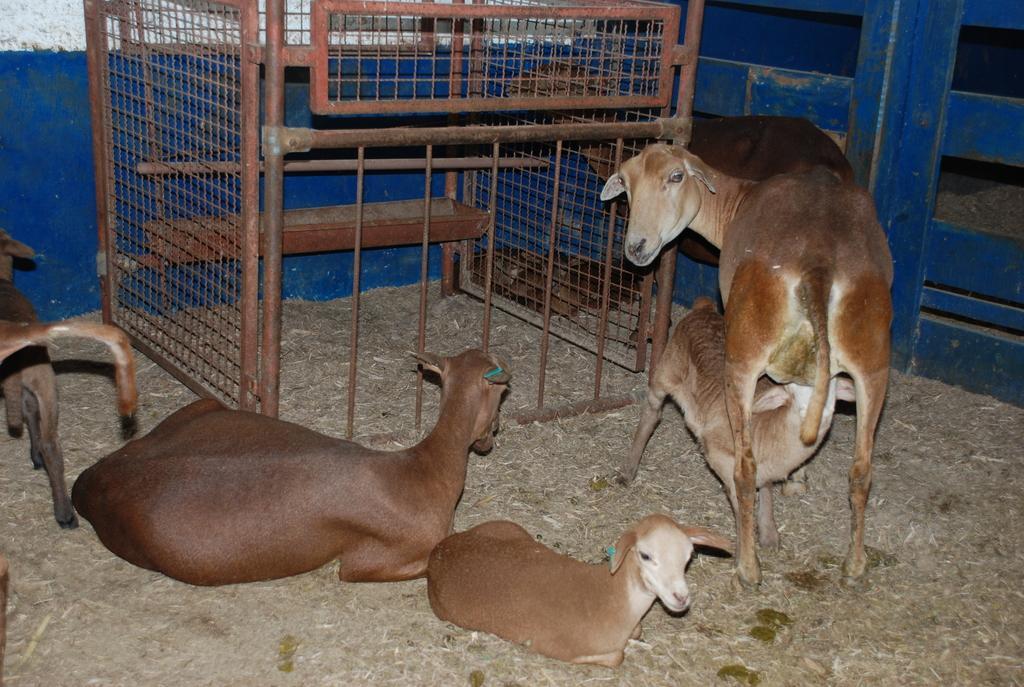How would you summarize this image in a sentence or two? In this image there are few goats on the ground. This is an iron structure. These are fences. 